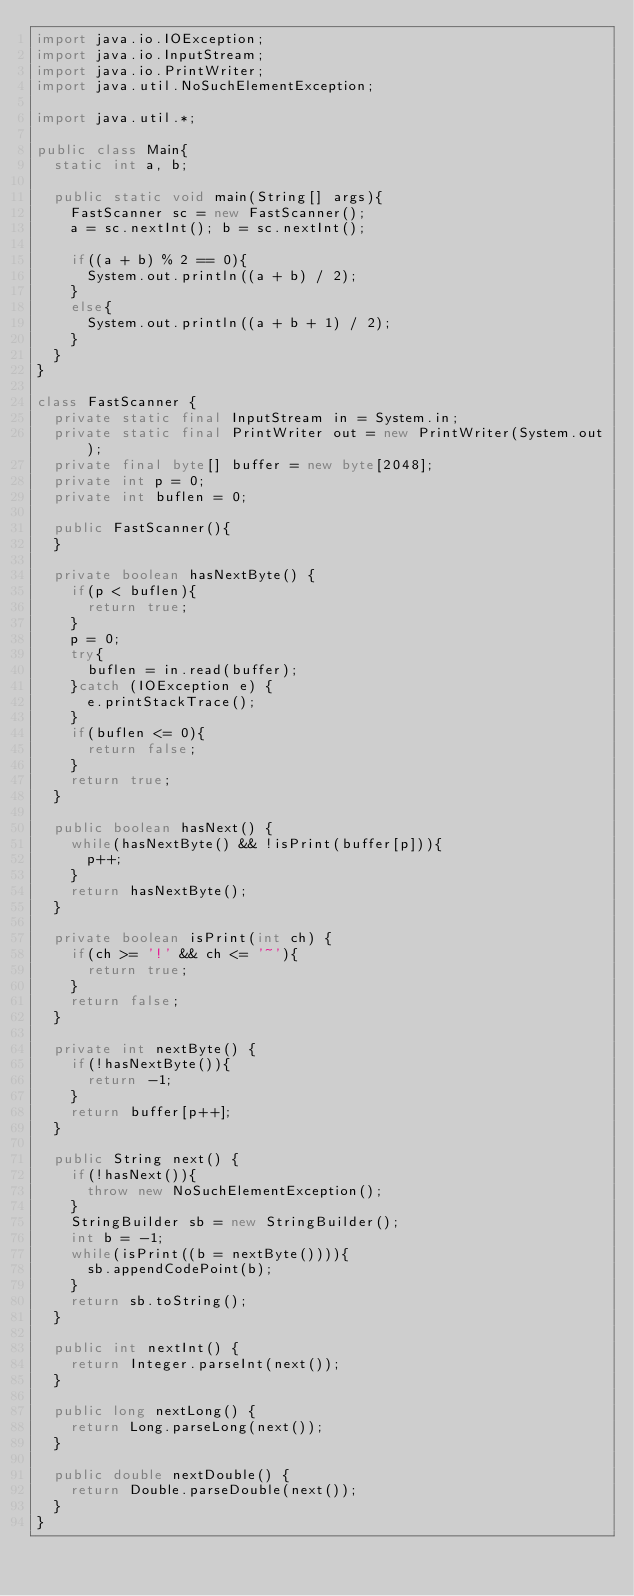<code> <loc_0><loc_0><loc_500><loc_500><_Java_>import java.io.IOException;
import java.io.InputStream;
import java.io.PrintWriter;
import java.util.NoSuchElementException;

import java.util.*;

public class Main{
  static int a, b;

  public static void main(String[] args){
    FastScanner sc = new FastScanner();
    a = sc.nextInt(); b = sc.nextInt();

    if((a + b) % 2 == 0){
      System.out.println((a + b) / 2);
    }
    else{
      System.out.println((a + b + 1) / 2);
    }
  }
}

class FastScanner {
  private static final InputStream in = System.in;
  private static final PrintWriter out = new PrintWriter(System.out);
  private final byte[] buffer = new byte[2048];
  private int p = 0;
  private int buflen = 0;

  public FastScanner(){
  }

  private boolean hasNextByte() {
    if(p < buflen){
      return true;
    }
    p = 0;
    try{
      buflen = in.read(buffer);
    }catch (IOException e) {
      e.printStackTrace();
    }
    if(buflen <= 0){
      return false;
    }
    return true;
  }

  public boolean hasNext() {
    while(hasNextByte() && !isPrint(buffer[p])){
      p++;
    }
    return hasNextByte();
  }

  private boolean isPrint(int ch) {
    if(ch >= '!' && ch <= '~'){
      return true;
    }
    return false;
  }

  private int nextByte() {
    if(!hasNextByte()){
      return -1;
    }
    return buffer[p++];
  }

  public String next() {
    if(!hasNext()){
      throw new NoSuchElementException();
    }
    StringBuilder sb = new StringBuilder();
    int b = -1;
    while(isPrint((b = nextByte()))){
      sb.appendCodePoint(b);
    }
    return sb.toString();
  }

  public int nextInt() {
    return Integer.parseInt(next());
  }

  public long nextLong() {
    return Long.parseLong(next());
  }

  public double nextDouble() {
    return Double.parseDouble(next());
  }
}
</code> 